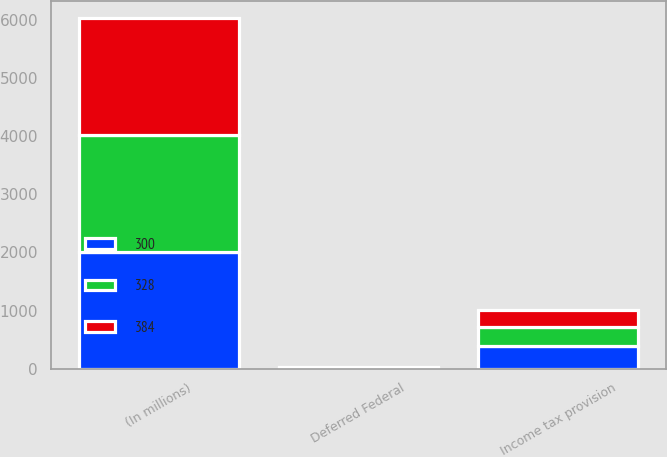<chart> <loc_0><loc_0><loc_500><loc_500><stacked_bar_chart><ecel><fcel>(In millions)<fcel>Deferred Federal<fcel>Income tax provision<nl><fcel>300<fcel>2014<fcel>4<fcel>384<nl><fcel>328<fcel>2013<fcel>12<fcel>328<nl><fcel>384<fcel>2012<fcel>3<fcel>300<nl></chart> 